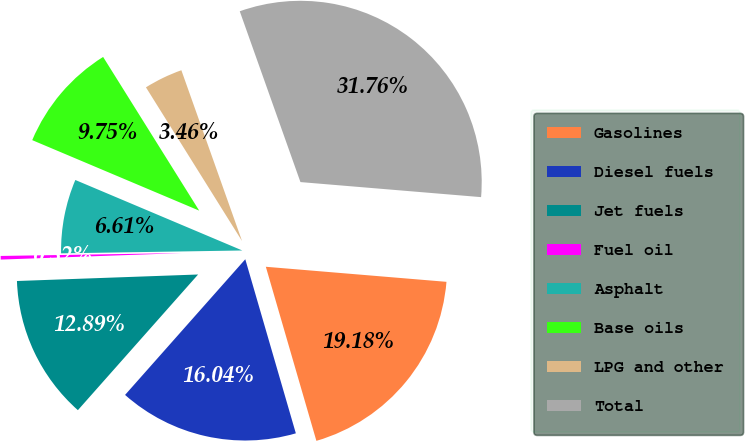Convert chart. <chart><loc_0><loc_0><loc_500><loc_500><pie_chart><fcel>Gasolines<fcel>Diesel fuels<fcel>Jet fuels<fcel>Fuel oil<fcel>Asphalt<fcel>Base oils<fcel>LPG and other<fcel>Total<nl><fcel>19.18%<fcel>16.04%<fcel>12.89%<fcel>0.32%<fcel>6.61%<fcel>9.75%<fcel>3.46%<fcel>31.76%<nl></chart> 